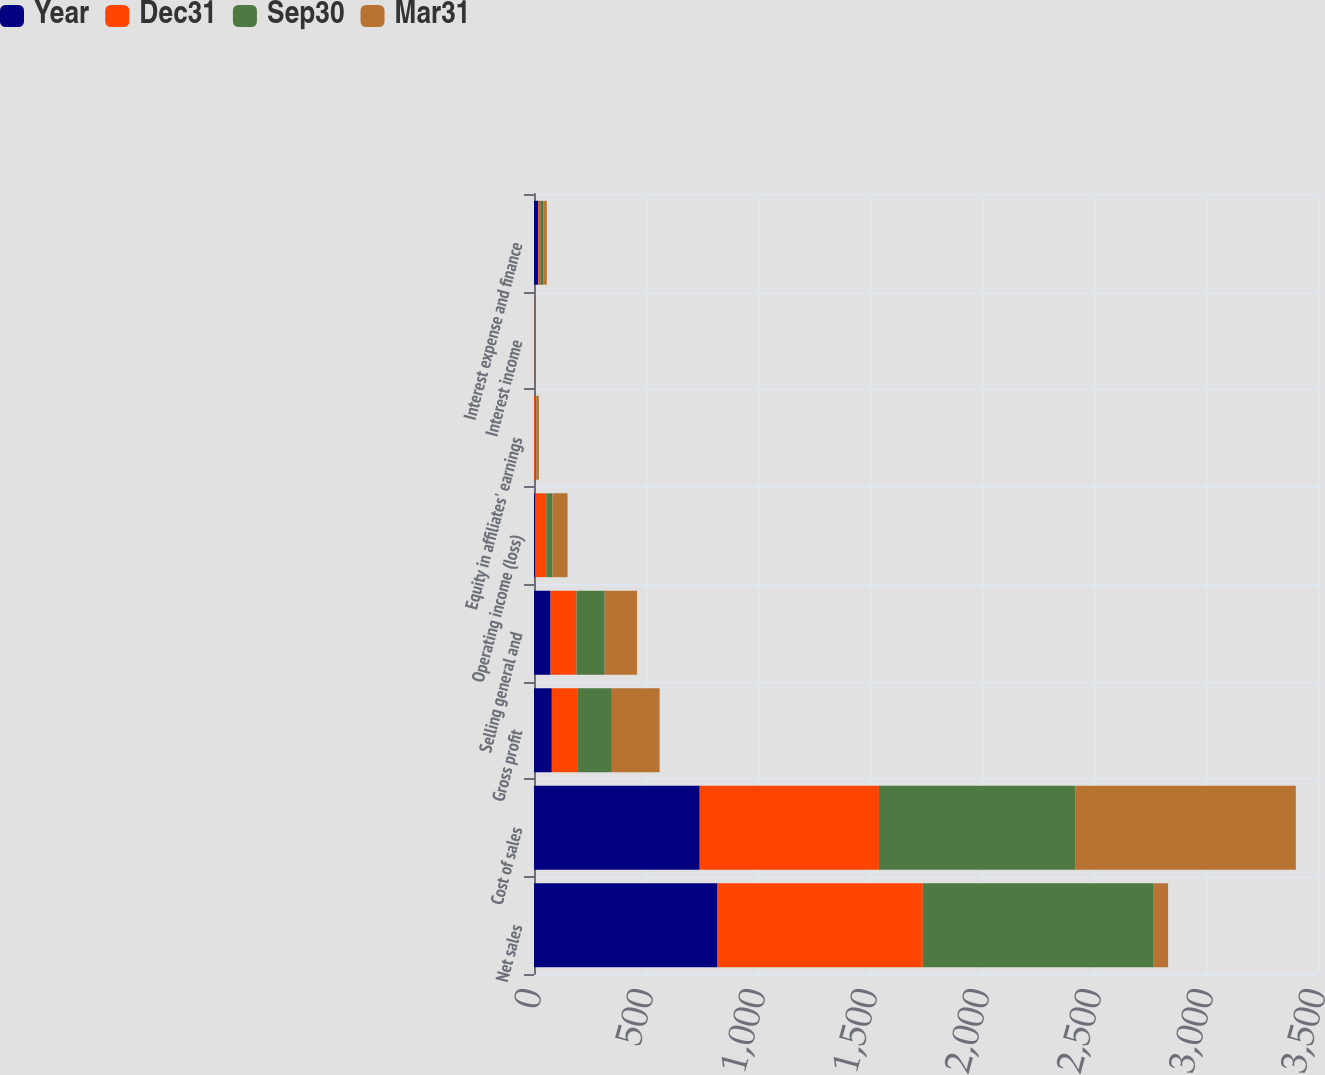Convert chart. <chart><loc_0><loc_0><loc_500><loc_500><stacked_bar_chart><ecel><fcel>Net sales<fcel>Cost of sales<fcel>Gross profit<fcel>Selling general and<fcel>Operating income (loss)<fcel>Equity in affiliates' earnings<fcel>Interest income<fcel>Interest expense and finance<nl><fcel>Year<fcel>819.5<fcel>739.9<fcel>79.6<fcel>74.1<fcel>5.5<fcel>0.2<fcel>0.5<fcel>19.1<nl><fcel>Dec31<fcel>916.2<fcel>800<fcel>116.2<fcel>115.4<fcel>49.5<fcel>4.8<fcel>0.7<fcel>9<nl><fcel>Sep30<fcel>1027.8<fcel>876<fcel>151.8<fcel>125.9<fcel>27.5<fcel>6.5<fcel>0.5<fcel>13<nl><fcel>Mar31<fcel>67.3<fcel>985.1<fcel>213.2<fcel>144.4<fcel>67.3<fcel>10.3<fcel>0.8<fcel>16.1<nl></chart> 